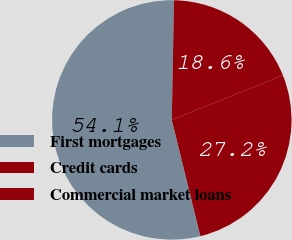Convert chart. <chart><loc_0><loc_0><loc_500><loc_500><pie_chart><fcel>First mortgages<fcel>Credit cards<fcel>Commercial market loans<nl><fcel>54.13%<fcel>27.23%<fcel>18.64%<nl></chart> 